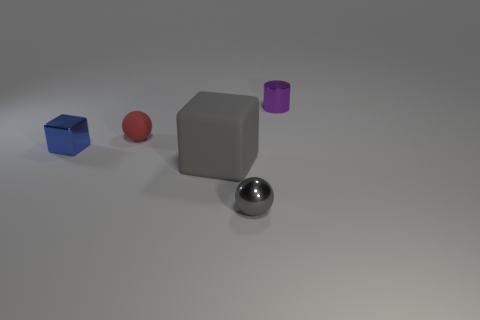Add 4 big green shiny spheres. How many objects exist? 9 Subtract all cylinders. How many objects are left? 4 Add 5 tiny metal cubes. How many tiny metal cubes exist? 6 Subtract 0 cyan spheres. How many objects are left? 5 Subtract all brown metallic blocks. Subtract all red objects. How many objects are left? 4 Add 2 purple objects. How many purple objects are left? 3 